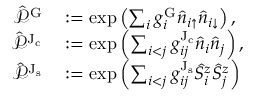Convert formula to latex. <formula><loc_0><loc_0><loc_500><loc_500>\begin{array} { r l } { \hat { \mathcal { P } } ^ { G } } & \colon = \exp \left ( \sum _ { i } g _ { i } ^ { G } \hat { n } _ { i { \uparrow } } \hat { n } _ { i { \downarrow } } \right ) , } \\ { \hat { \mathcal { P } } ^ { J _ { c } } } & \colon = \exp \left ( \sum _ { i < j } g _ { i j } ^ { J _ { c } } \hat { n } _ { i } \hat { n } _ { j } \right ) , } \\ { \hat { \mathcal { P } } ^ { J _ { s } } } & \colon = \exp \left ( \sum _ { i < j } g _ { i j } ^ { J _ { s } } \hat { S } _ { i } ^ { z } \hat { S } _ { j } ^ { z } \right ) } \end{array}</formula> 